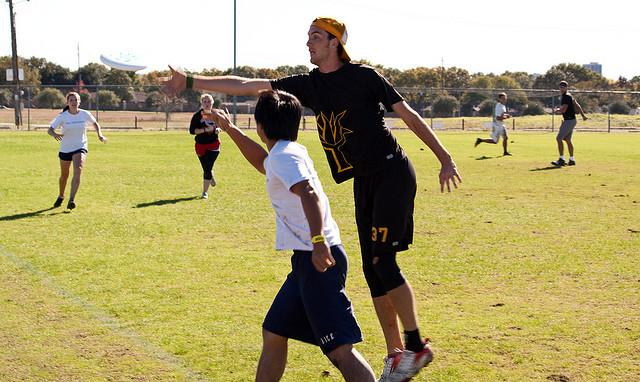What sport are the people playing? Please explain your reasoning. ultimate frisbee. These people are playing ultimate frisbee as evidenced by the white frisbee they are trying to grab. 